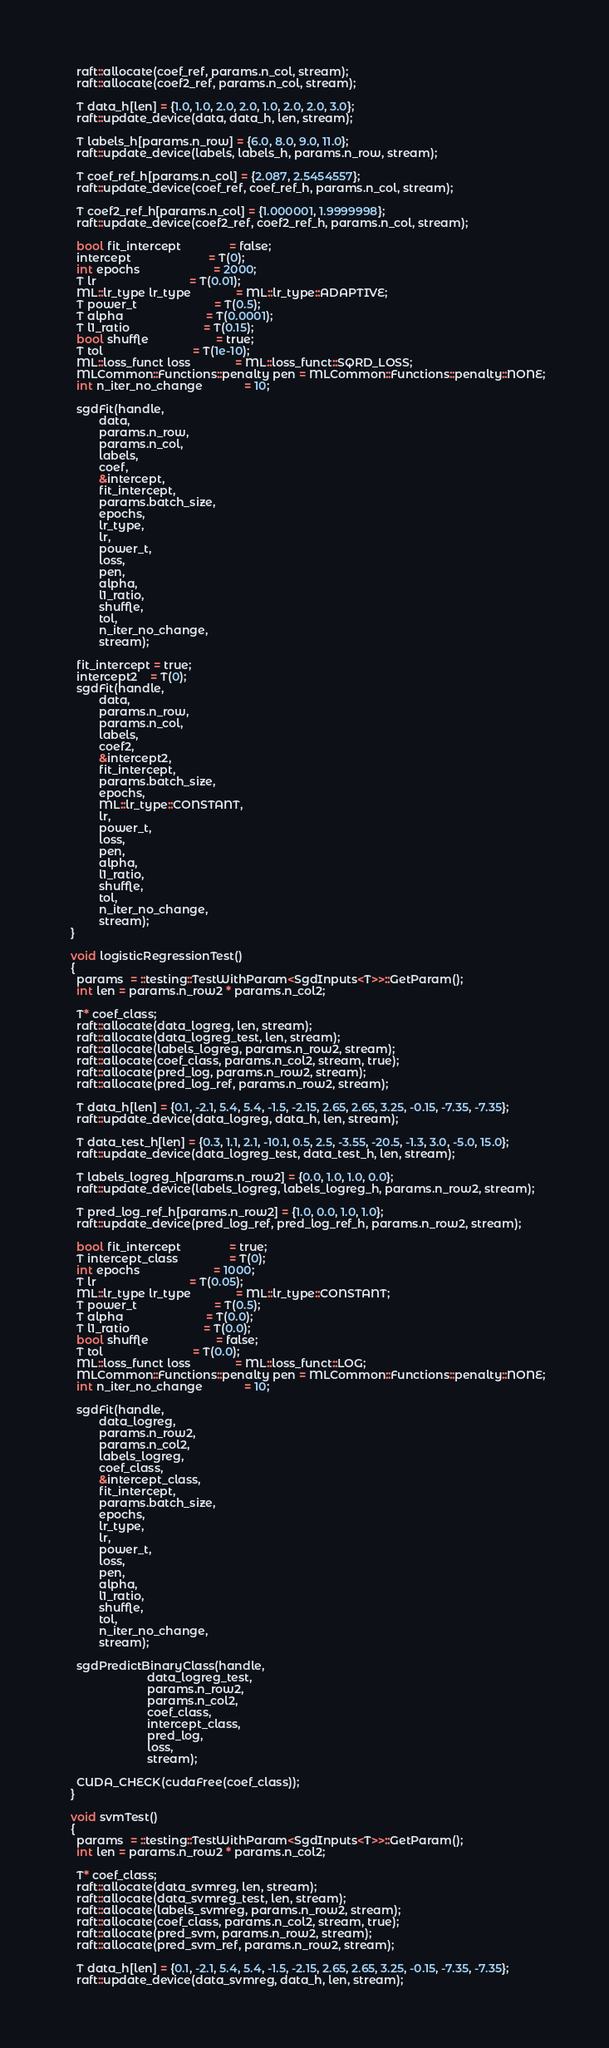<code> <loc_0><loc_0><loc_500><loc_500><_Cuda_>    raft::allocate(coef_ref, params.n_col, stream);
    raft::allocate(coef2_ref, params.n_col, stream);

    T data_h[len] = {1.0, 1.0, 2.0, 2.0, 1.0, 2.0, 2.0, 3.0};
    raft::update_device(data, data_h, len, stream);

    T labels_h[params.n_row] = {6.0, 8.0, 9.0, 11.0};
    raft::update_device(labels, labels_h, params.n_row, stream);

    T coef_ref_h[params.n_col] = {2.087, 2.5454557};
    raft::update_device(coef_ref, coef_ref_h, params.n_col, stream);

    T coef2_ref_h[params.n_col] = {1.000001, 1.9999998};
    raft::update_device(coef2_ref, coef2_ref_h, params.n_col, stream);

    bool fit_intercept               = false;
    intercept                        = T(0);
    int epochs                       = 2000;
    T lr                             = T(0.01);
    ML::lr_type lr_type              = ML::lr_type::ADAPTIVE;
    T power_t                        = T(0.5);
    T alpha                          = T(0.0001);
    T l1_ratio                       = T(0.15);
    bool shuffle                     = true;
    T tol                            = T(1e-10);
    ML::loss_funct loss              = ML::loss_funct::SQRD_LOSS;
    MLCommon::Functions::penalty pen = MLCommon::Functions::penalty::NONE;
    int n_iter_no_change             = 10;

    sgdFit(handle,
           data,
           params.n_row,
           params.n_col,
           labels,
           coef,
           &intercept,
           fit_intercept,
           params.batch_size,
           epochs,
           lr_type,
           lr,
           power_t,
           loss,
           pen,
           alpha,
           l1_ratio,
           shuffle,
           tol,
           n_iter_no_change,
           stream);

    fit_intercept = true;
    intercept2    = T(0);
    sgdFit(handle,
           data,
           params.n_row,
           params.n_col,
           labels,
           coef2,
           &intercept2,
           fit_intercept,
           params.batch_size,
           epochs,
           ML::lr_type::CONSTANT,
           lr,
           power_t,
           loss,
           pen,
           alpha,
           l1_ratio,
           shuffle,
           tol,
           n_iter_no_change,
           stream);
  }

  void logisticRegressionTest()
  {
    params  = ::testing::TestWithParam<SgdInputs<T>>::GetParam();
    int len = params.n_row2 * params.n_col2;

    T* coef_class;
    raft::allocate(data_logreg, len, stream);
    raft::allocate(data_logreg_test, len, stream);
    raft::allocate(labels_logreg, params.n_row2, stream);
    raft::allocate(coef_class, params.n_col2, stream, true);
    raft::allocate(pred_log, params.n_row2, stream);
    raft::allocate(pred_log_ref, params.n_row2, stream);

    T data_h[len] = {0.1, -2.1, 5.4, 5.4, -1.5, -2.15, 2.65, 2.65, 3.25, -0.15, -7.35, -7.35};
    raft::update_device(data_logreg, data_h, len, stream);

    T data_test_h[len] = {0.3, 1.1, 2.1, -10.1, 0.5, 2.5, -3.55, -20.5, -1.3, 3.0, -5.0, 15.0};
    raft::update_device(data_logreg_test, data_test_h, len, stream);

    T labels_logreg_h[params.n_row2] = {0.0, 1.0, 1.0, 0.0};
    raft::update_device(labels_logreg, labels_logreg_h, params.n_row2, stream);

    T pred_log_ref_h[params.n_row2] = {1.0, 0.0, 1.0, 1.0};
    raft::update_device(pred_log_ref, pred_log_ref_h, params.n_row2, stream);

    bool fit_intercept               = true;
    T intercept_class                = T(0);
    int epochs                       = 1000;
    T lr                             = T(0.05);
    ML::lr_type lr_type              = ML::lr_type::CONSTANT;
    T power_t                        = T(0.5);
    T alpha                          = T(0.0);
    T l1_ratio                       = T(0.0);
    bool shuffle                     = false;
    T tol                            = T(0.0);
    ML::loss_funct loss              = ML::loss_funct::LOG;
    MLCommon::Functions::penalty pen = MLCommon::Functions::penalty::NONE;
    int n_iter_no_change             = 10;

    sgdFit(handle,
           data_logreg,
           params.n_row2,
           params.n_col2,
           labels_logreg,
           coef_class,
           &intercept_class,
           fit_intercept,
           params.batch_size,
           epochs,
           lr_type,
           lr,
           power_t,
           loss,
           pen,
           alpha,
           l1_ratio,
           shuffle,
           tol,
           n_iter_no_change,
           stream);

    sgdPredictBinaryClass(handle,
                          data_logreg_test,
                          params.n_row2,
                          params.n_col2,
                          coef_class,
                          intercept_class,
                          pred_log,
                          loss,
                          stream);

    CUDA_CHECK(cudaFree(coef_class));
  }

  void svmTest()
  {
    params  = ::testing::TestWithParam<SgdInputs<T>>::GetParam();
    int len = params.n_row2 * params.n_col2;

    T* coef_class;
    raft::allocate(data_svmreg, len, stream);
    raft::allocate(data_svmreg_test, len, stream);
    raft::allocate(labels_svmreg, params.n_row2, stream);
    raft::allocate(coef_class, params.n_col2, stream, true);
    raft::allocate(pred_svm, params.n_row2, stream);
    raft::allocate(pred_svm_ref, params.n_row2, stream);

    T data_h[len] = {0.1, -2.1, 5.4, 5.4, -1.5, -2.15, 2.65, 2.65, 3.25, -0.15, -7.35, -7.35};
    raft::update_device(data_svmreg, data_h, len, stream);
</code> 